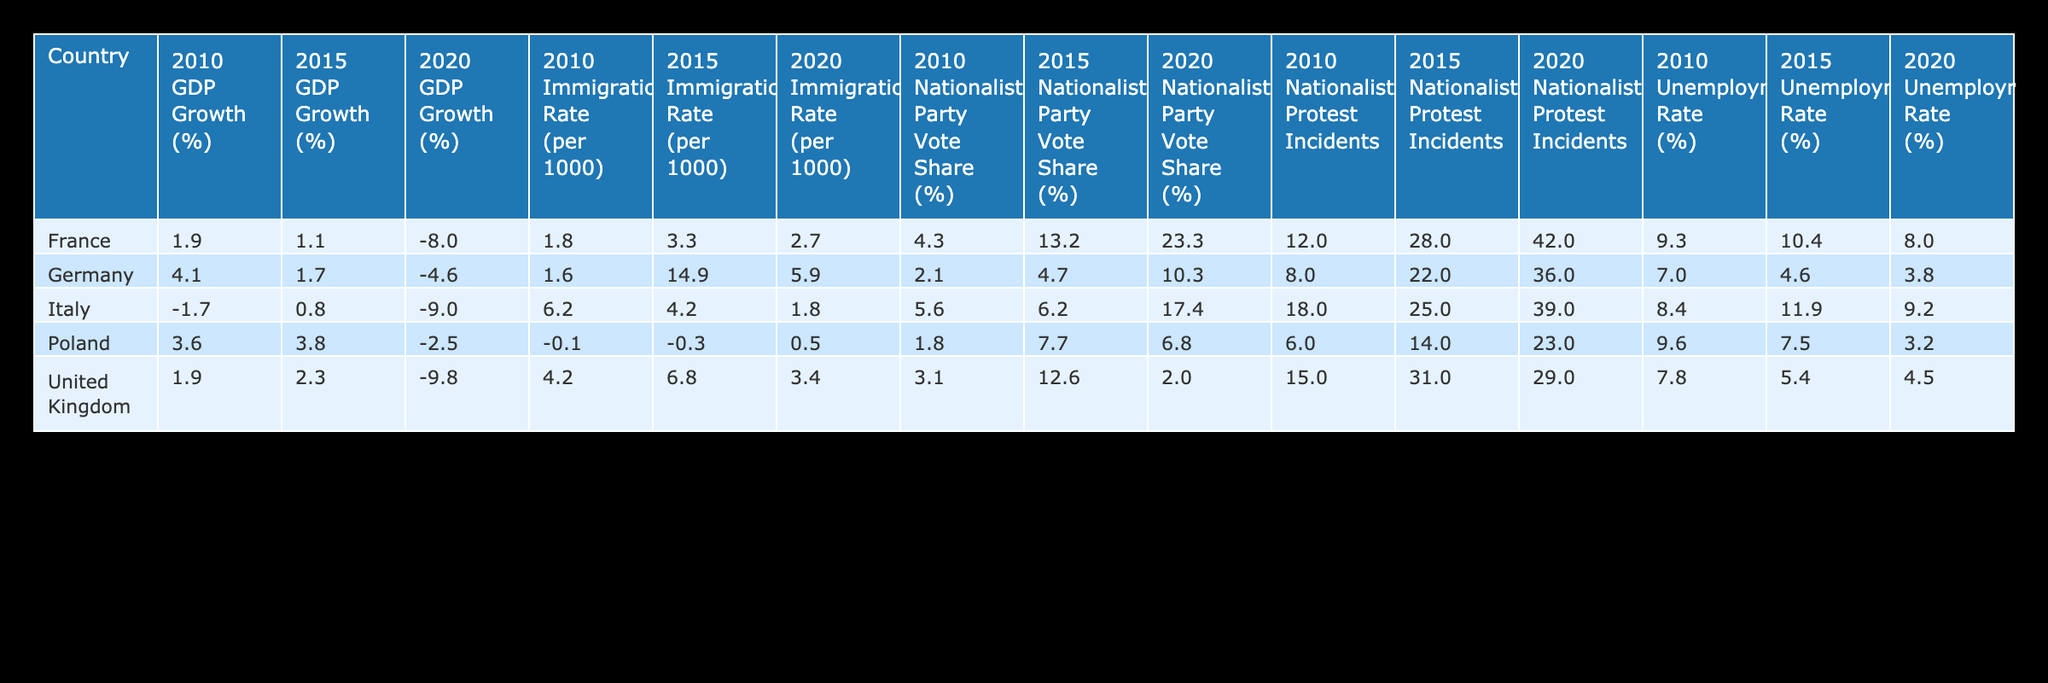What was the GDP growth percentage for France in 2020? In the row for France under the column for the year 2020, the GDP growth percentage is listed as -8.0.
Answer: -8.0 Which country had the highest Nationalist Party Vote Share in 2015, and what was the percentage? Looking at the data for 2015, France has the highest Nationalist Party Vote Share with 13.2%.
Answer: France, 13.2% Is it true that Germany's Unemployment Rate decreased from 2010 to 2015? By comparing the Unemployment Rate for Germany in 2010 (7.0%) and 2015 (4.6%), we can see that it did indeed decrease.
Answer: Yes What is the average Nationalist Protest Incidents across all countries in 2020? The Nationalist Protest Incidents in 2020 are 42 for France, 36 for Germany, 29 for the United Kingdom, 39 for Italy, and 23 for Poland. Summing these gives 169, and there are 5 countries, so the average is 169 / 5 = 33.8.
Answer: 33.8 In which year did Italy experience the most significant decline in GDP growth, and what was the rate? The GDP growth percentage for Italy in 2010 is -1.7%, in 2015 it is 0.8%, and in 2020 it is -9.0%. The most significant decline is in 2020 with -9.0%.
Answer: 2020, -9.0% Which country had the lowest Immigration Rate in 2015 and what was the value? In the data for 2015, Poland had the lowest Immigration Rate at -0.3.
Answer: Poland, -0.3 Did any country have a rise in Nationalist Party Vote Share from 2010 to 2020? Comparing the Nationalist Party Vote Share in both years, France rose from 4.3% to 23.3%, indicating an increase, while Germany, the UK, Italy, and Poland all had lower values in 2020.
Answer: Yes What is the difference in Unemployment Rate between France and Italy in 2010? In 2010, France's Unemployment Rate is 9.3% and Italy's is 8.4%. The difference is 9.3% - 8.4% = 0.9%.
Answer: 0.9% 